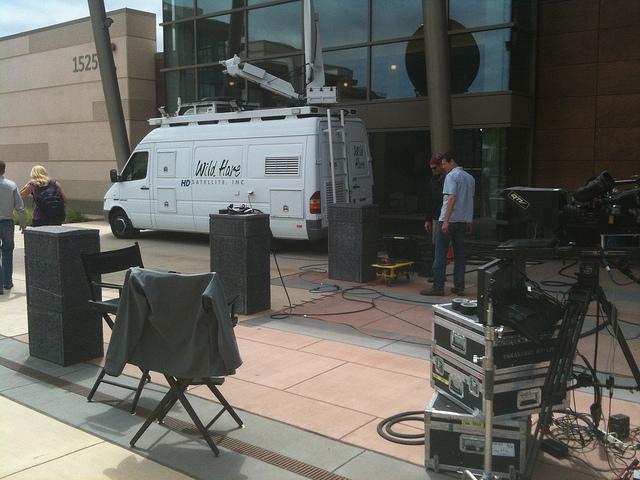How many bikes are there?
Give a very brief answer. 0. How many chairs are there?
Give a very brief answer. 2. How many people are there?
Give a very brief answer. 2. How many trucks are there?
Give a very brief answer. 1. How many motorcycles are there?
Give a very brief answer. 0. 